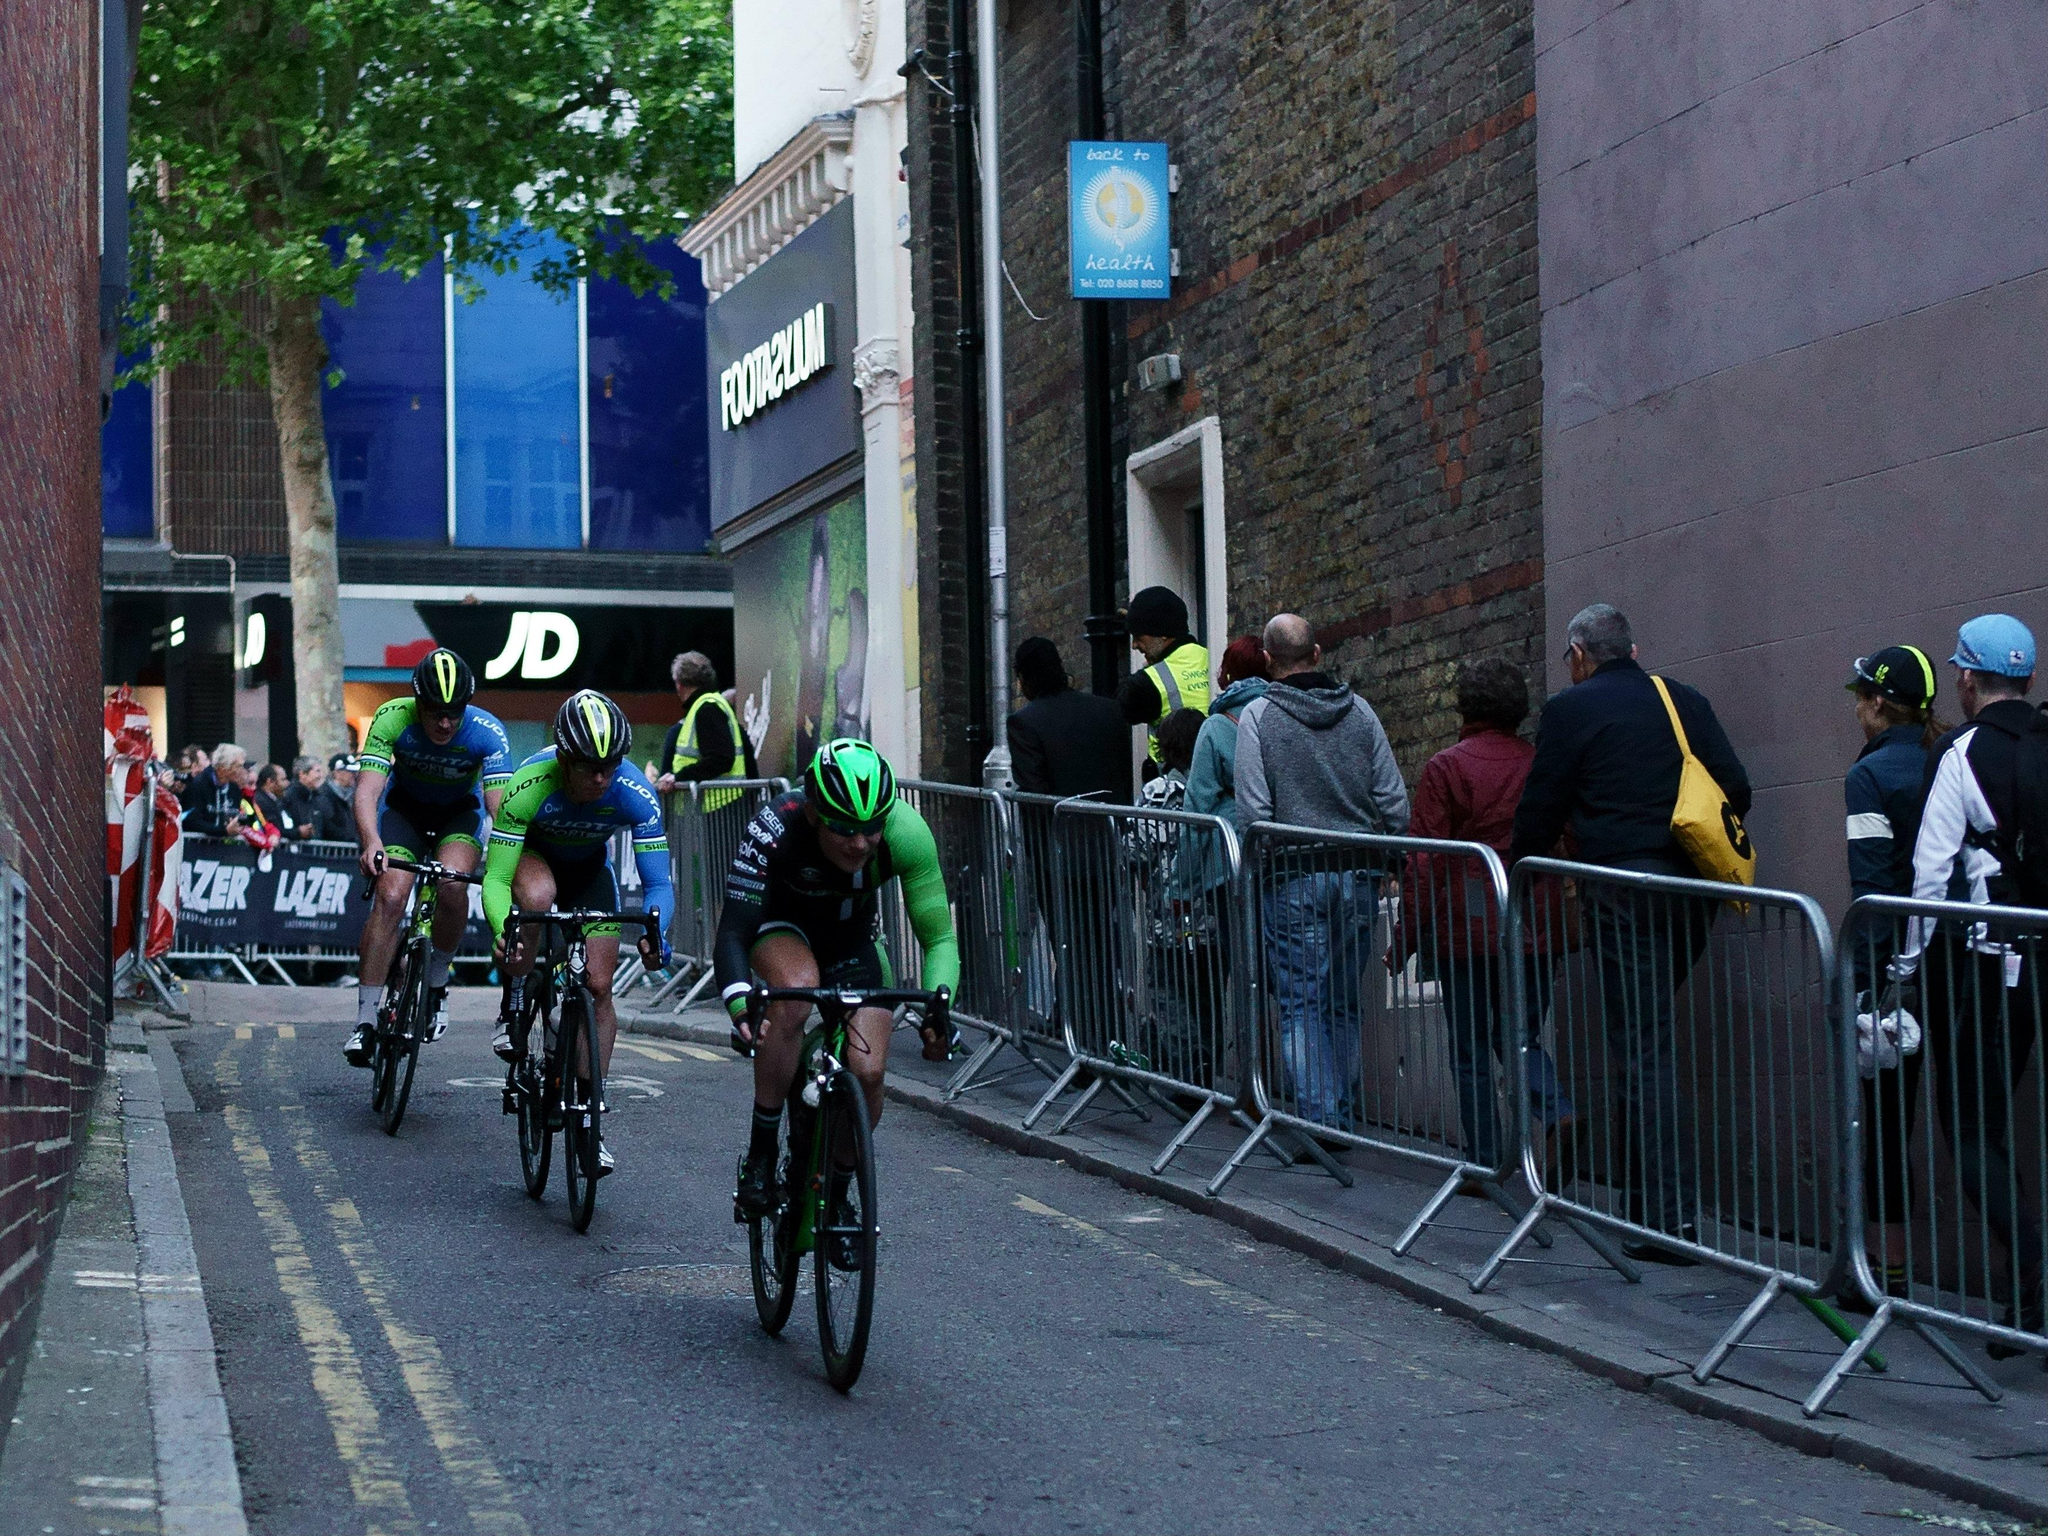What type of structures can be seen in the image? There are buildings in the image. What additional object is present in the image? There is a banner in the image. What natural element is visible in the image? There is a tree in the image. What man-made feature can be seen in the image? There is a fence in the image. Who or what else is present in the image? There are people in the image. What activity are some of the people engaged in? Some people are riding bicycles in the image. Can you tell me how many monkeys are sitting on the banner in the image? There are no monkeys present in the image; the banner is the only object mentioned in the facts. What type of bun is being served at the event depicted in the image? There is no mention of a bun or any event in the image or the provided facts. 